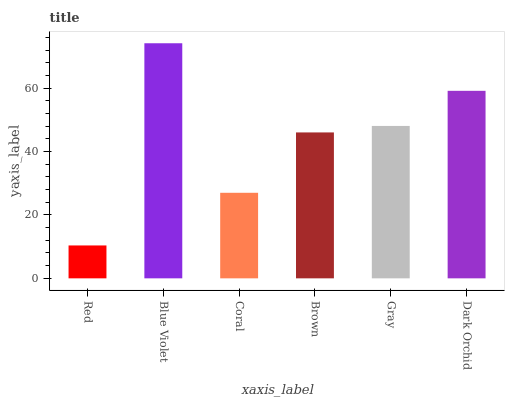Is Red the minimum?
Answer yes or no. Yes. Is Blue Violet the maximum?
Answer yes or no. Yes. Is Coral the minimum?
Answer yes or no. No. Is Coral the maximum?
Answer yes or no. No. Is Blue Violet greater than Coral?
Answer yes or no. Yes. Is Coral less than Blue Violet?
Answer yes or no. Yes. Is Coral greater than Blue Violet?
Answer yes or no. No. Is Blue Violet less than Coral?
Answer yes or no. No. Is Gray the high median?
Answer yes or no. Yes. Is Brown the low median?
Answer yes or no. Yes. Is Dark Orchid the high median?
Answer yes or no. No. Is Red the low median?
Answer yes or no. No. 